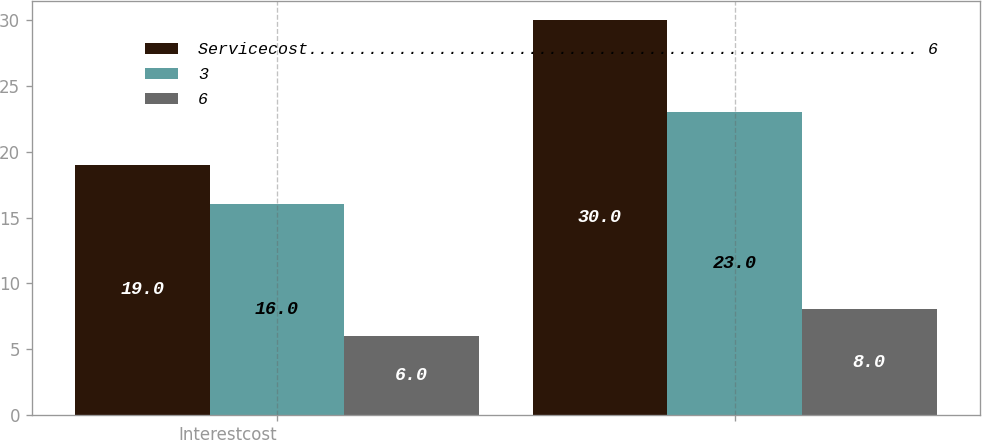<chart> <loc_0><loc_0><loc_500><loc_500><stacked_bar_chart><ecel><fcel>Interestcost<fcel>Unnamed: 2<nl><fcel>Servicecost............................................................. 6<fcel>19<fcel>30<nl><fcel>3<fcel>16<fcel>23<nl><fcel>6<fcel>6<fcel>8<nl></chart> 